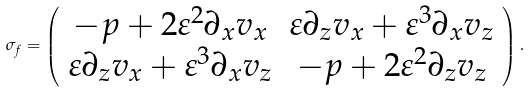<formula> <loc_0><loc_0><loc_500><loc_500>\sigma _ { f } = \left ( \begin{array} { c c } - p + 2 \varepsilon ^ { 2 } \partial _ { x } v _ { x } & \varepsilon \partial _ { z } v _ { x } + \varepsilon ^ { 3 } \partial _ { x } v _ { z } \\ \varepsilon \partial _ { z } v _ { x } + \varepsilon ^ { 3 } \partial _ { x } v _ { z } & - p + 2 \varepsilon ^ { 2 } \partial _ { z } v _ { z } \end{array} \right ) .</formula> 